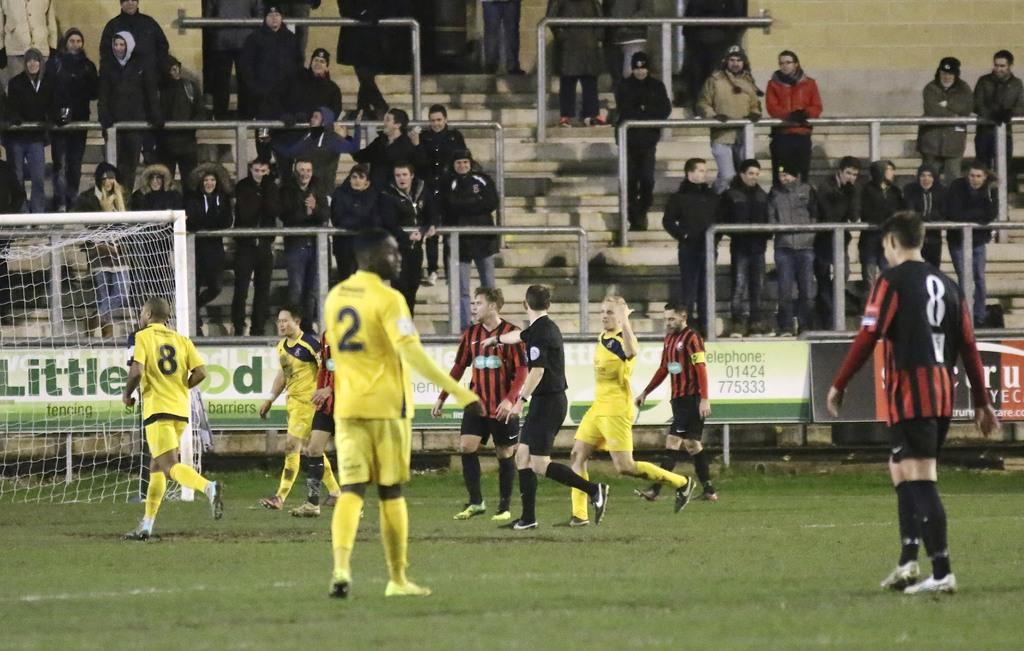What is the primary setting of the image? The primary setting of the image is a ground. What can be seen on the ground in the image? There are players standing on the ground in the image. Who else is present in the image besides the players? There are audience members standing at the back in the image. What type of vegetation is visible in the image? There is grass in the image. What is located on the left side of the image? There is a net on the left side of the image. How many islands can be seen in the image? There are no islands present in the image. What type of development is taking place in the image? There is no development taking place in the image; it is a scene of a game or sporting event. 